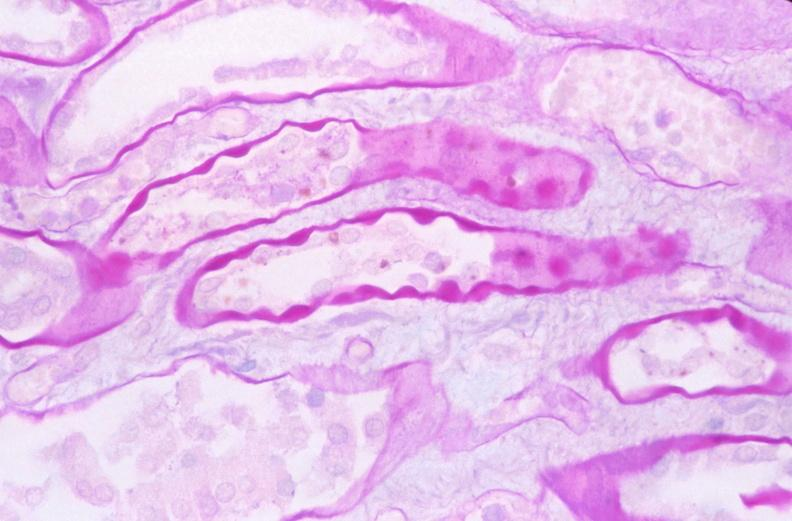does this image show kidney, thickened and hyalinized basement membranes due to diabetes mellitus, pas?
Answer the question using a single word or phrase. Yes 